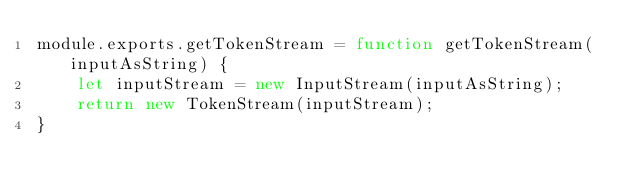Convert code to text. <code><loc_0><loc_0><loc_500><loc_500><_JavaScript_>module.exports.getTokenStream = function getTokenStream(inputAsString) {
    let inputStream = new InputStream(inputAsString);
    return new TokenStream(inputStream);
}</code> 